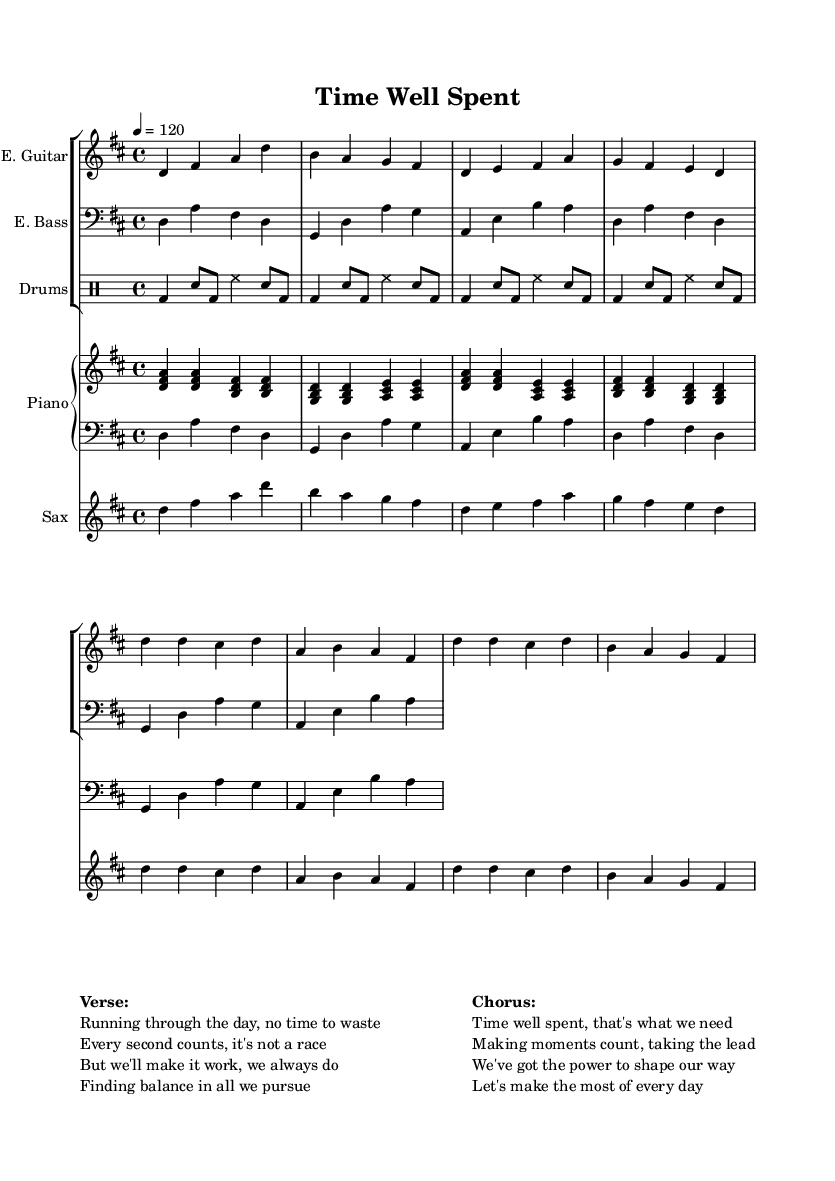What is the key signature of this music? The key signature is D major, which includes two sharps: F# and C#. This can be identified in the global settings, where it specifies "\key d \major".
Answer: D major What is the time signature of this music? The time signature is 4/4, which indicates that there are four beats in a measure. This is denoted in the global settings with "\time 4/4".
Answer: 4/4 What is the tempo marking for this piece? The tempo marking is 120 beats per minute. This is indicated in the global settings with "\tempo 4 = 120".
Answer: 120 How many measures are indicated in the drum part? The drum part contains four measures, as evidenced by the repeated pattern in the drummode section, which counts four groups of beats.
Answer: 4 How many instruments are featured in this music? There are five distinct instruments represented: Electric Guitar, Electric Bass, Drums, Piano (with both hands), and Saxophone. This can be inferred from the instrument names provided in the score sections.
Answer: 5 What type of song structure does this composition follow based on the lyrics? The song structure follows a verse-chorus format, which is evident in the organization of the lyrics portion, where the "Verse" is followed by the "Chorus".
Answer: Verse-Chorus What is the overall mood conveyed through the lyrics? The lyrics convey an empowering mood, focused on making the most of each day and finding balance, as highlighted in both the verse and chorus. This is inferred from the key phrases within the lyrics.
Answer: Empowering 